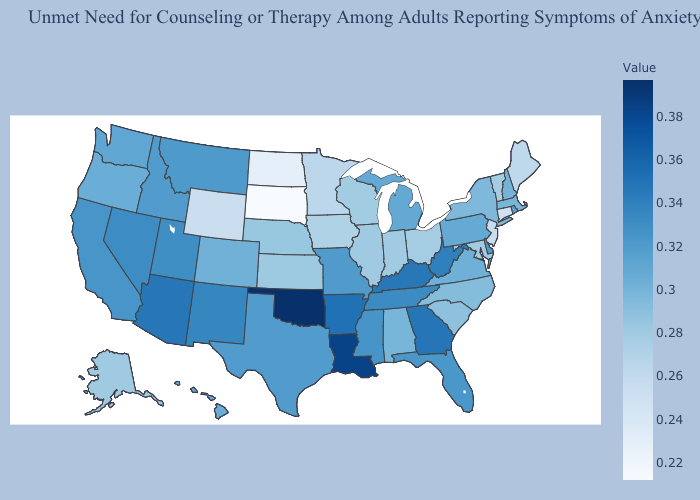Among the states that border Minnesota , does South Dakota have the highest value?
Concise answer only. No. Which states have the lowest value in the MidWest?
Keep it brief. South Dakota. Which states hav the highest value in the West?
Write a very short answer. Arizona. Among the states that border West Virginia , does Ohio have the lowest value?
Be succinct. Yes. Does Massachusetts have the highest value in the Northeast?
Answer briefly. No. Which states have the lowest value in the South?
Answer briefly. Maryland. 